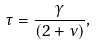Convert formula to latex. <formula><loc_0><loc_0><loc_500><loc_500>\tau = \frac { \gamma } { \left ( 2 + \nu \right ) } ,</formula> 